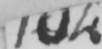Please provide the text content of this handwritten line. 104 